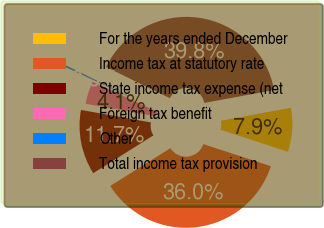<chart> <loc_0><loc_0><loc_500><loc_500><pie_chart><fcel>For the years ended December<fcel>Income tax at statutory rate<fcel>State income tax expense (net<fcel>Foreign tax benefit<fcel>Other<fcel>Total income tax provision<nl><fcel>7.93%<fcel>36.05%<fcel>11.74%<fcel>4.12%<fcel>0.31%<fcel>39.85%<nl></chart> 